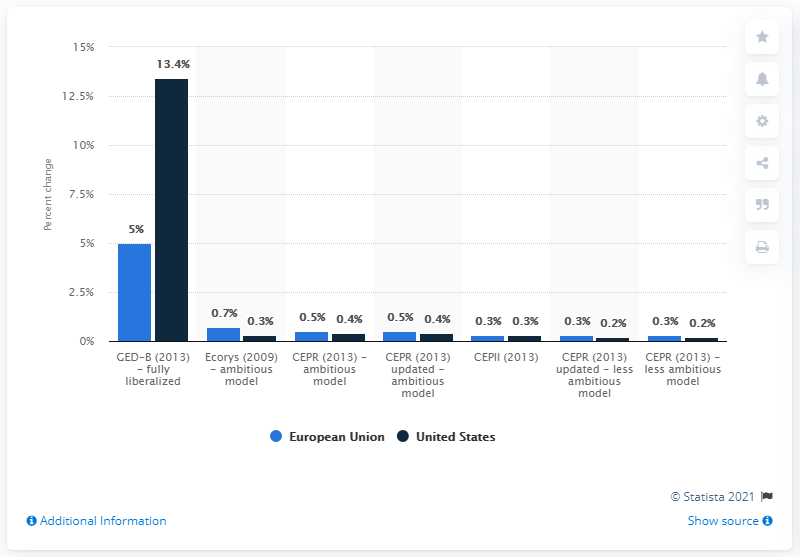Outline some significant characteristics in this image. According to the 2013 CEPII study model, TTIP is projected to increase EU GDP by 0.3%. 